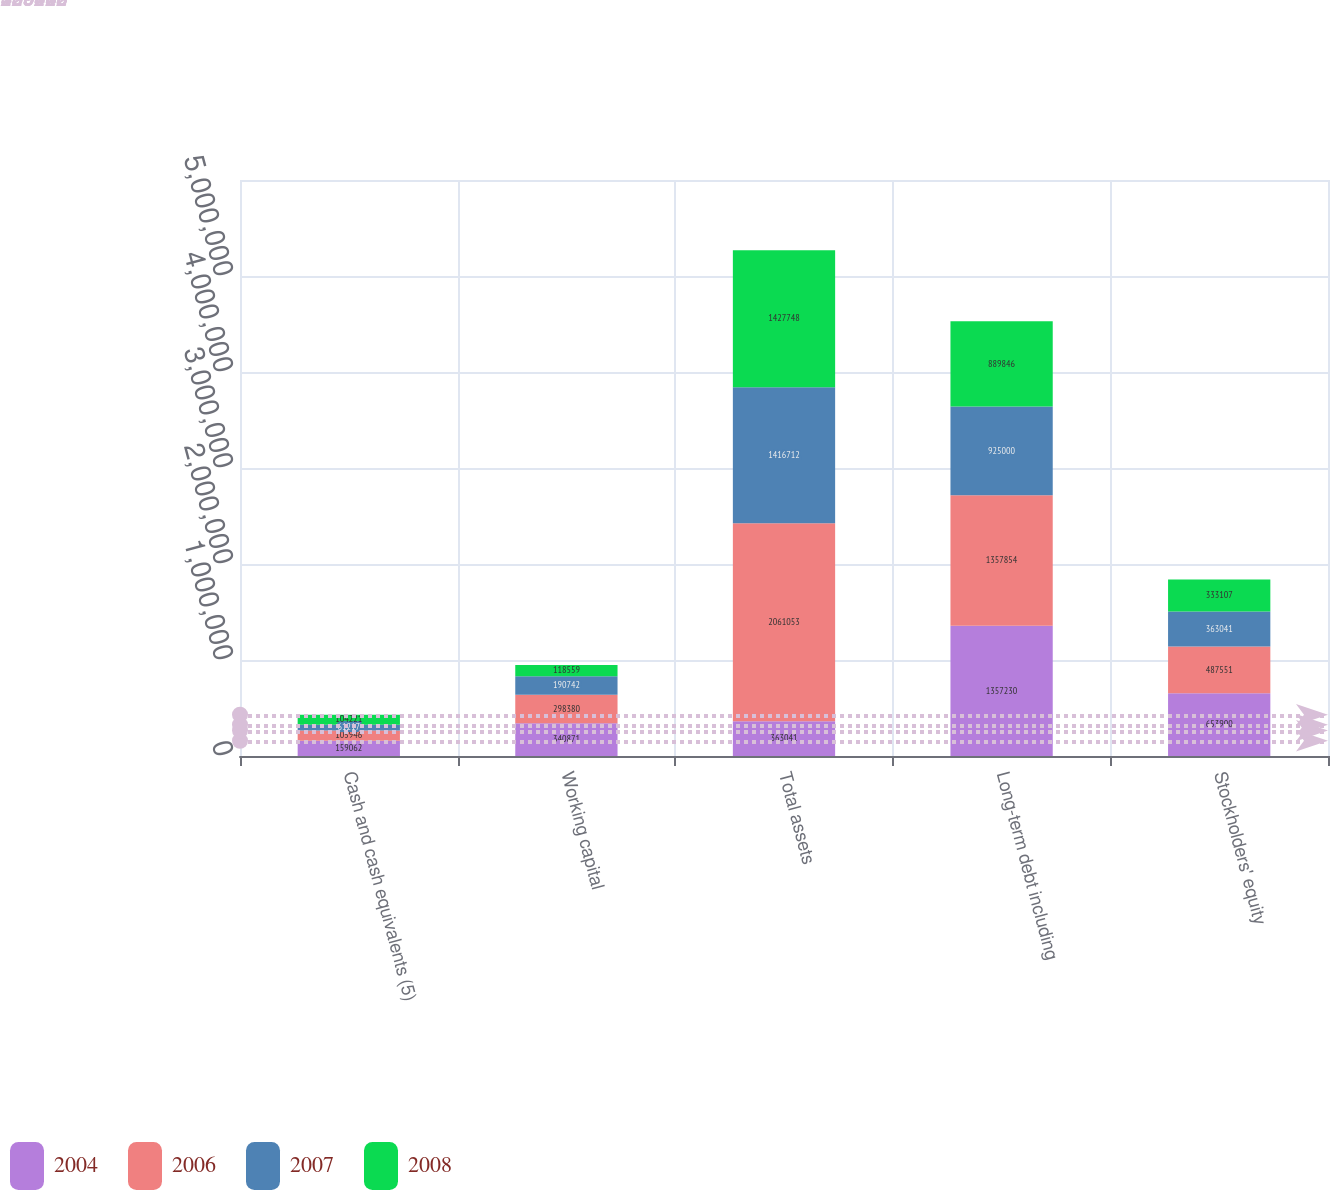Convert chart to OTSL. <chart><loc_0><loc_0><loc_500><loc_500><stacked_bar_chart><ecel><fcel>Cash and cash equivalents (5)<fcel>Working capital<fcel>Total assets<fcel>Long-term debt including<fcel>Stockholders' equity<nl><fcel>2004<fcel>159062<fcel>340871<fcel>363041<fcel>1.35723e+06<fcel>653900<nl><fcel>2006<fcel>105946<fcel>298380<fcel>2.06105e+06<fcel>1.35785e+06<fcel>487551<nl><fcel>2007<fcel>61217<fcel>190742<fcel>1.41671e+06<fcel>925000<fcel>363041<nl><fcel>2008<fcel>104221<fcel>118559<fcel>1.42775e+06<fcel>889846<fcel>333107<nl></chart> 